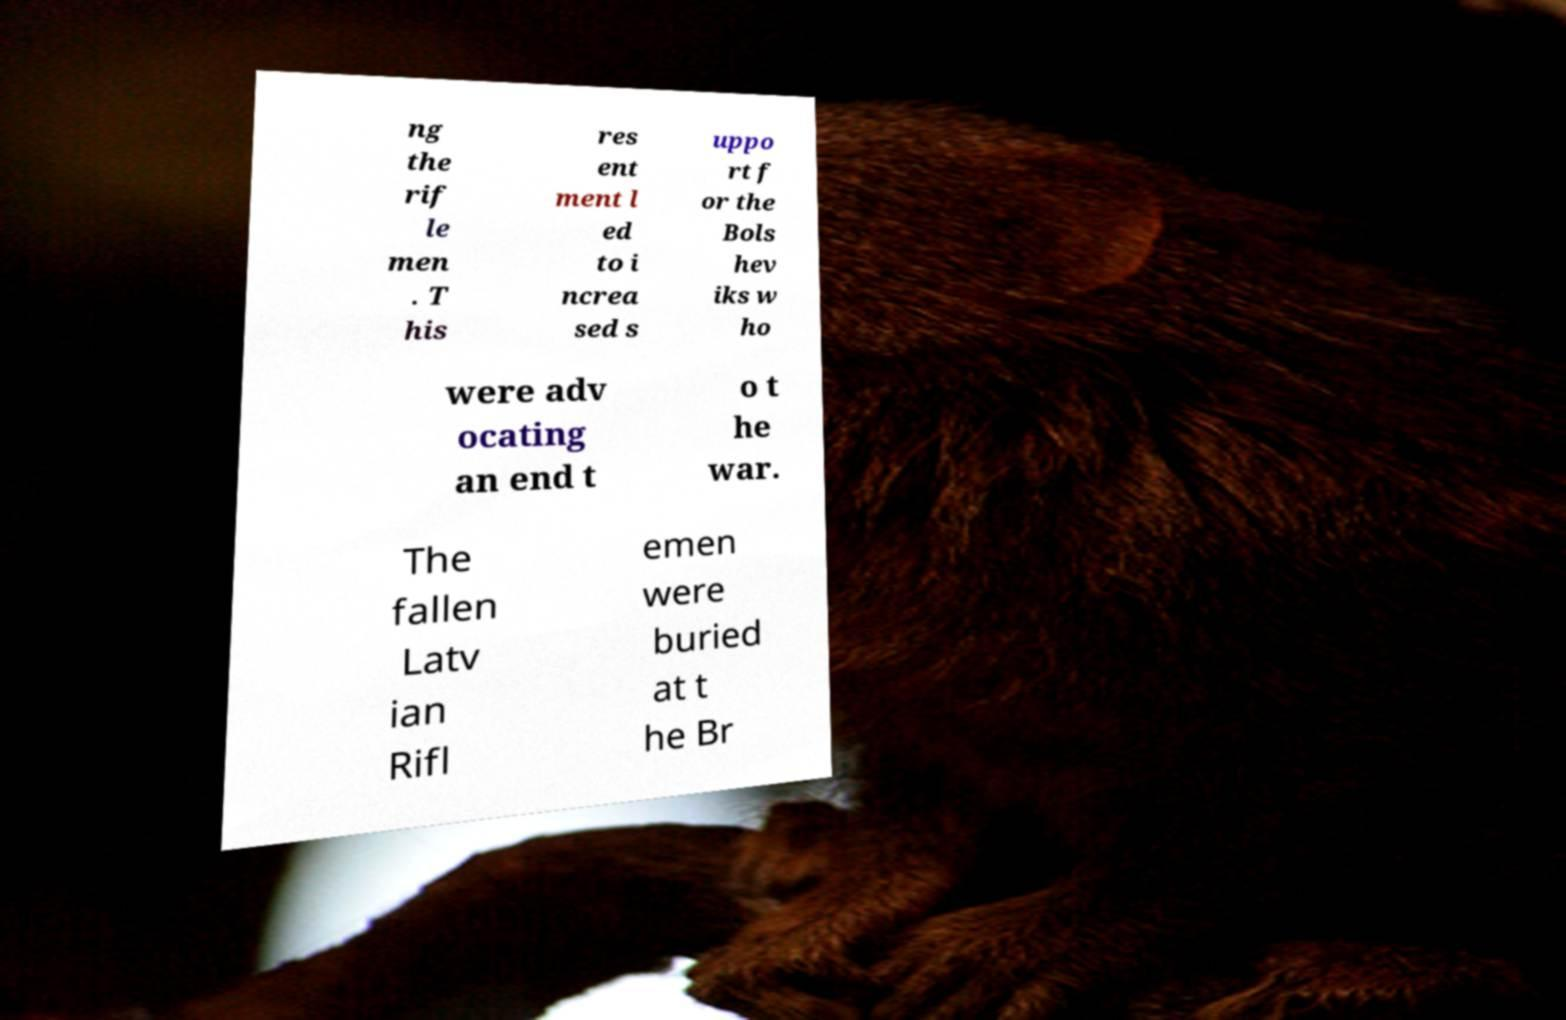Please identify and transcribe the text found in this image. ng the rif le men . T his res ent ment l ed to i ncrea sed s uppo rt f or the Bols hev iks w ho were adv ocating an end t o t he war. The fallen Latv ian Rifl emen were buried at t he Br 